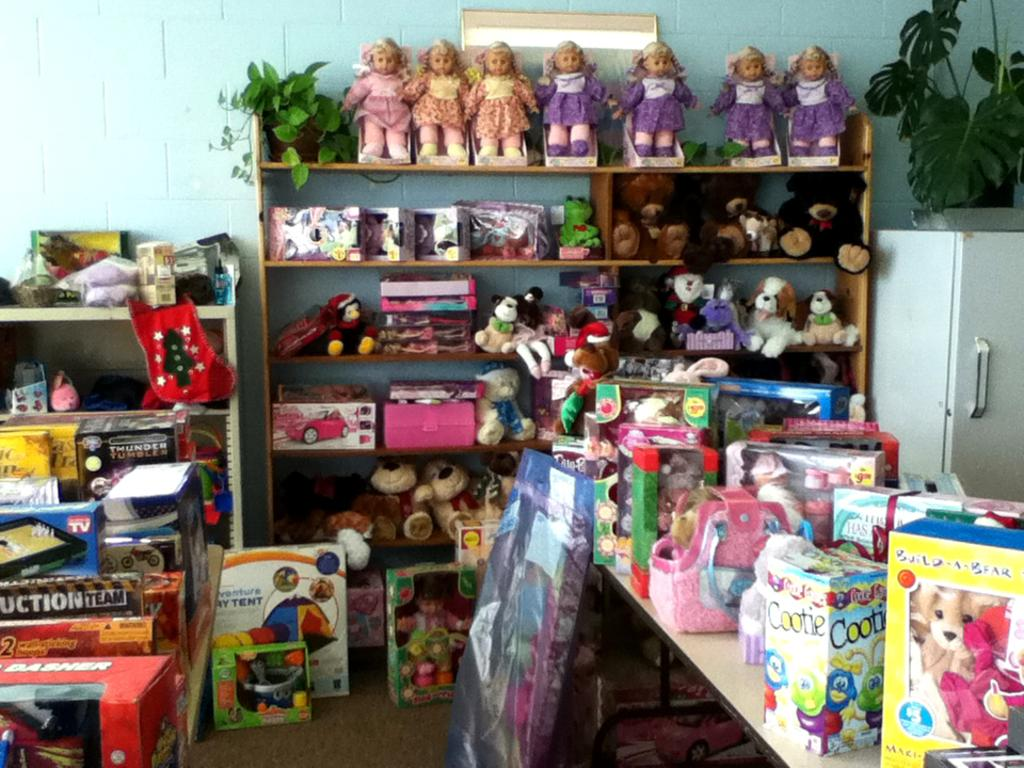<image>
Write a terse but informative summary of the picture. a series of games with one that says team on it 